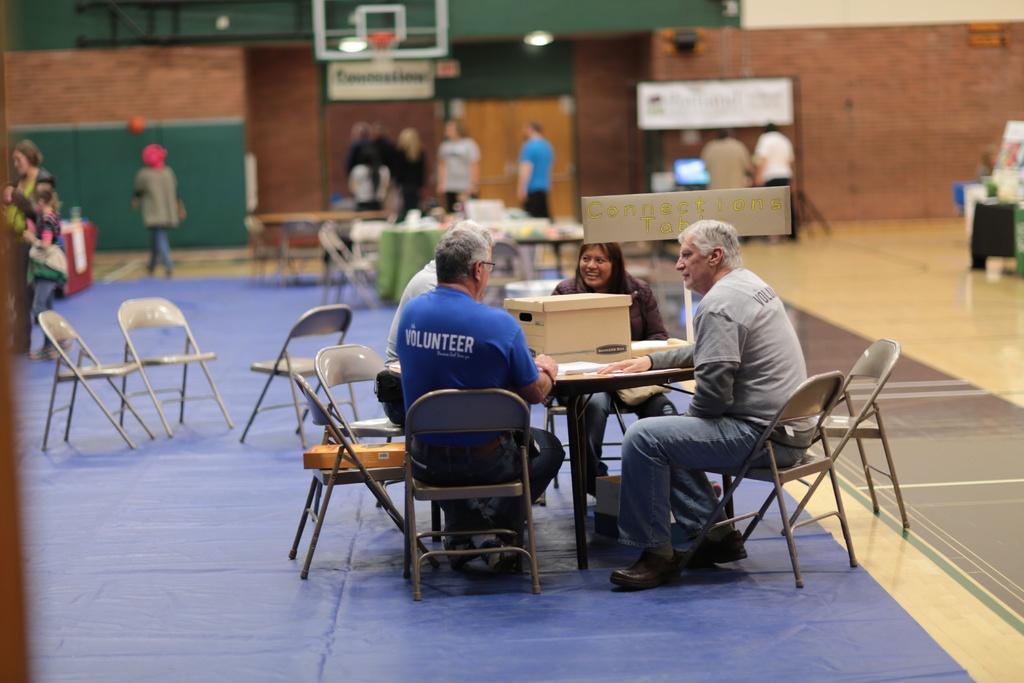How would you summarize this image in a sentence or two? The picture is from a basketball court. In the foreground of the picture there are four people seated in chairs around the table, on the table there is a box. In the picture there are many chairs and tables. In the background there is a desktop. In the top of the background there is a brick wall and a basket. In the background there are many people walking. Floor is covered with blue color mat. 